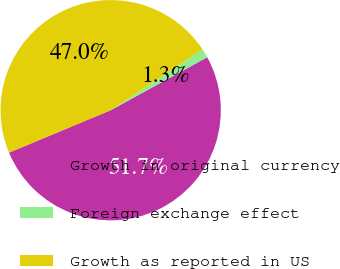Convert chart to OTSL. <chart><loc_0><loc_0><loc_500><loc_500><pie_chart><fcel>Growth in original currency<fcel>Foreign exchange effect<fcel>Growth as reported in US<nl><fcel>51.7%<fcel>1.31%<fcel>47.0%<nl></chart> 